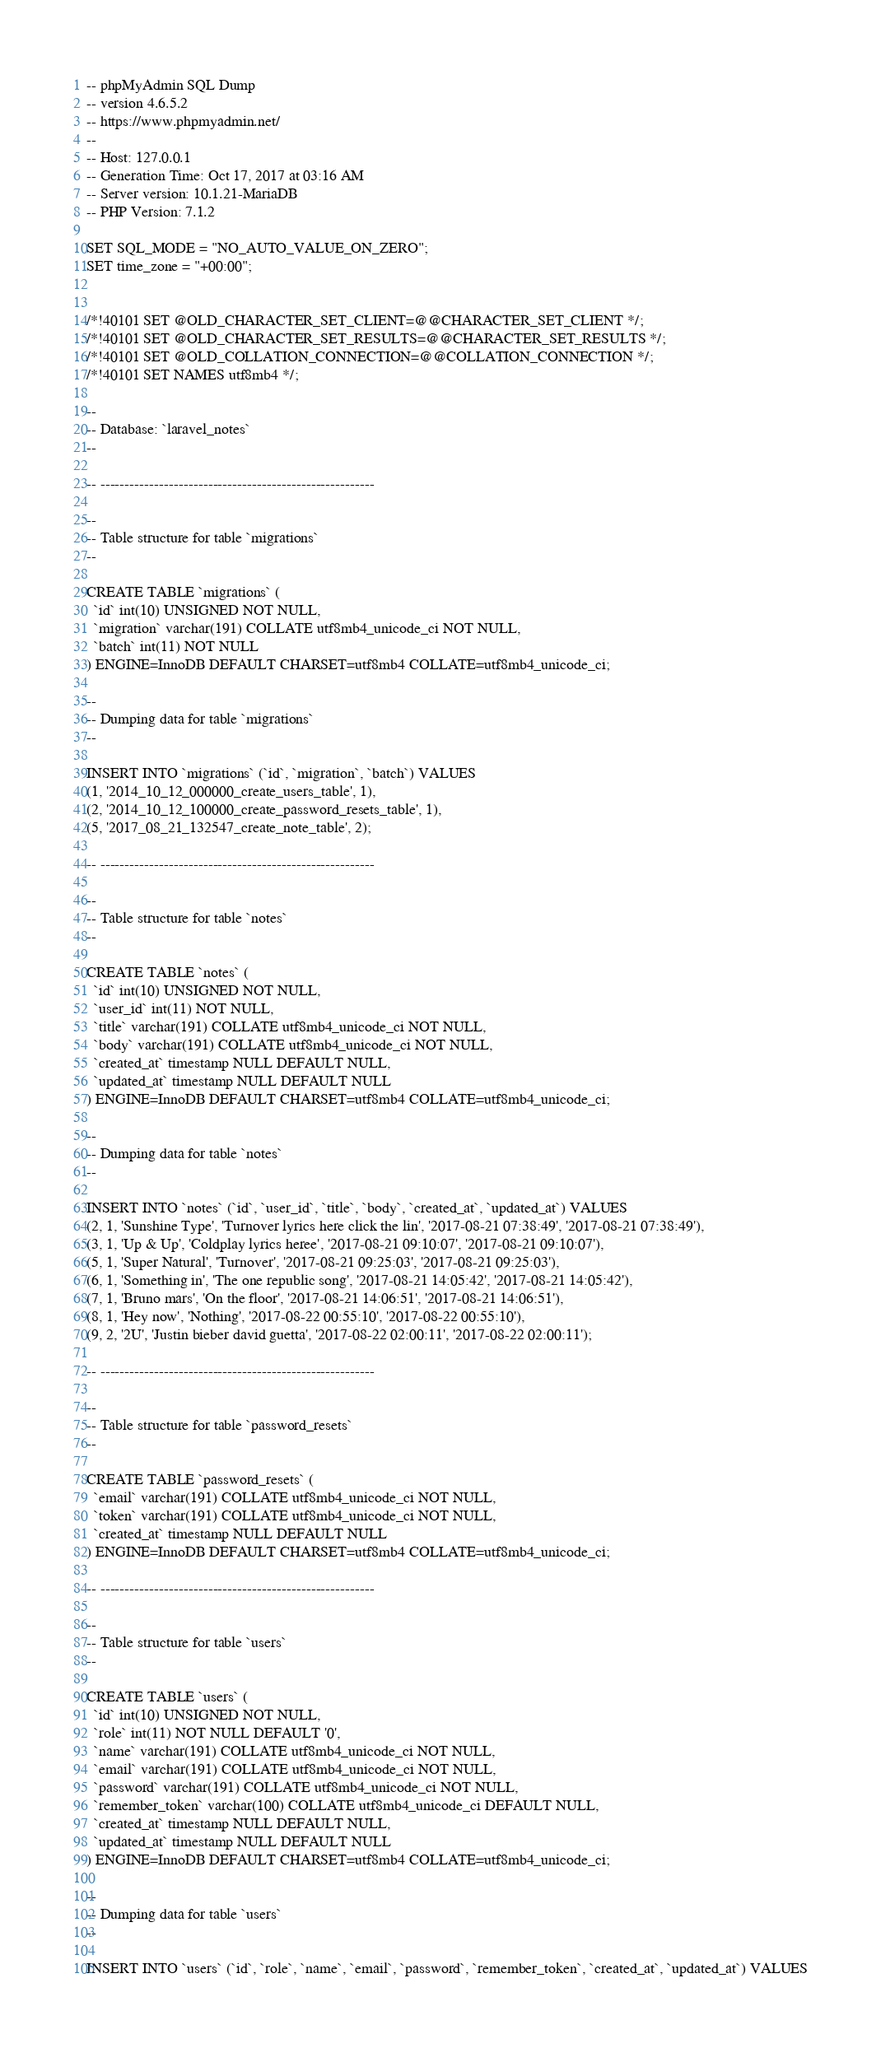Convert code to text. <code><loc_0><loc_0><loc_500><loc_500><_SQL_>-- phpMyAdmin SQL Dump
-- version 4.6.5.2
-- https://www.phpmyadmin.net/
--
-- Host: 127.0.0.1
-- Generation Time: Oct 17, 2017 at 03:16 AM
-- Server version: 10.1.21-MariaDB
-- PHP Version: 7.1.2

SET SQL_MODE = "NO_AUTO_VALUE_ON_ZERO";
SET time_zone = "+00:00";


/*!40101 SET @OLD_CHARACTER_SET_CLIENT=@@CHARACTER_SET_CLIENT */;
/*!40101 SET @OLD_CHARACTER_SET_RESULTS=@@CHARACTER_SET_RESULTS */;
/*!40101 SET @OLD_COLLATION_CONNECTION=@@COLLATION_CONNECTION */;
/*!40101 SET NAMES utf8mb4 */;

--
-- Database: `laravel_notes`
--

-- --------------------------------------------------------

--
-- Table structure for table `migrations`
--

CREATE TABLE `migrations` (
  `id` int(10) UNSIGNED NOT NULL,
  `migration` varchar(191) COLLATE utf8mb4_unicode_ci NOT NULL,
  `batch` int(11) NOT NULL
) ENGINE=InnoDB DEFAULT CHARSET=utf8mb4 COLLATE=utf8mb4_unicode_ci;

--
-- Dumping data for table `migrations`
--

INSERT INTO `migrations` (`id`, `migration`, `batch`) VALUES
(1, '2014_10_12_000000_create_users_table', 1),
(2, '2014_10_12_100000_create_password_resets_table', 1),
(5, '2017_08_21_132547_create_note_table', 2);

-- --------------------------------------------------------

--
-- Table structure for table `notes`
--

CREATE TABLE `notes` (
  `id` int(10) UNSIGNED NOT NULL,
  `user_id` int(11) NOT NULL,
  `title` varchar(191) COLLATE utf8mb4_unicode_ci NOT NULL,
  `body` varchar(191) COLLATE utf8mb4_unicode_ci NOT NULL,
  `created_at` timestamp NULL DEFAULT NULL,
  `updated_at` timestamp NULL DEFAULT NULL
) ENGINE=InnoDB DEFAULT CHARSET=utf8mb4 COLLATE=utf8mb4_unicode_ci;

--
-- Dumping data for table `notes`
--

INSERT INTO `notes` (`id`, `user_id`, `title`, `body`, `created_at`, `updated_at`) VALUES
(2, 1, 'Sunshine Type', 'Turnover lyrics here click the lin', '2017-08-21 07:38:49', '2017-08-21 07:38:49'),
(3, 1, 'Up & Up', 'Coldplay lyrics heree', '2017-08-21 09:10:07', '2017-08-21 09:10:07'),
(5, 1, 'Super Natural', 'Turnover', '2017-08-21 09:25:03', '2017-08-21 09:25:03'),
(6, 1, 'Something in', 'The one republic song', '2017-08-21 14:05:42', '2017-08-21 14:05:42'),
(7, 1, 'Bruno mars', 'On the floor', '2017-08-21 14:06:51', '2017-08-21 14:06:51'),
(8, 1, 'Hey now', 'Nothing', '2017-08-22 00:55:10', '2017-08-22 00:55:10'),
(9, 2, '2U', 'Justin bieber david guetta', '2017-08-22 02:00:11', '2017-08-22 02:00:11');

-- --------------------------------------------------------

--
-- Table structure for table `password_resets`
--

CREATE TABLE `password_resets` (
  `email` varchar(191) COLLATE utf8mb4_unicode_ci NOT NULL,
  `token` varchar(191) COLLATE utf8mb4_unicode_ci NOT NULL,
  `created_at` timestamp NULL DEFAULT NULL
) ENGINE=InnoDB DEFAULT CHARSET=utf8mb4 COLLATE=utf8mb4_unicode_ci;

-- --------------------------------------------------------

--
-- Table structure for table `users`
--

CREATE TABLE `users` (
  `id` int(10) UNSIGNED NOT NULL,
  `role` int(11) NOT NULL DEFAULT '0',
  `name` varchar(191) COLLATE utf8mb4_unicode_ci NOT NULL,
  `email` varchar(191) COLLATE utf8mb4_unicode_ci NOT NULL,
  `password` varchar(191) COLLATE utf8mb4_unicode_ci NOT NULL,
  `remember_token` varchar(100) COLLATE utf8mb4_unicode_ci DEFAULT NULL,
  `created_at` timestamp NULL DEFAULT NULL,
  `updated_at` timestamp NULL DEFAULT NULL
) ENGINE=InnoDB DEFAULT CHARSET=utf8mb4 COLLATE=utf8mb4_unicode_ci;

--
-- Dumping data for table `users`
--

INSERT INTO `users` (`id`, `role`, `name`, `email`, `password`, `remember_token`, `created_at`, `updated_at`) VALUES</code> 